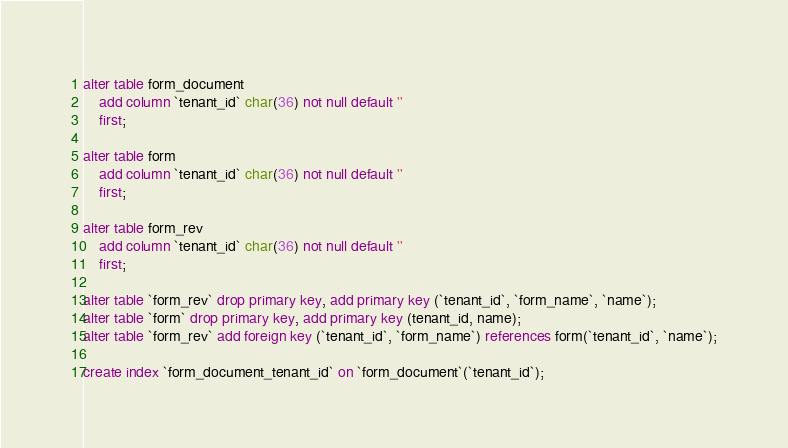Convert code to text. <code><loc_0><loc_0><loc_500><loc_500><_SQL_>
alter table form_document 
	add column `tenant_id` char(36) not null default ''
	first;

alter table form 
	add column `tenant_id` char(36) not null default ''
	first;

alter table form_rev 
	add column `tenant_id` char(36) not null default ''
	first;

alter table `form_rev` drop primary key, add primary key (`tenant_id`, `form_name`, `name`);
alter table `form` drop primary key, add primary key (tenant_id, name);
alter table `form_rev` add foreign key (`tenant_id`, `form_name`) references form(`tenant_id`, `name`);

create index `form_document_tenant_id` on `form_document`(`tenant_id`);</code> 